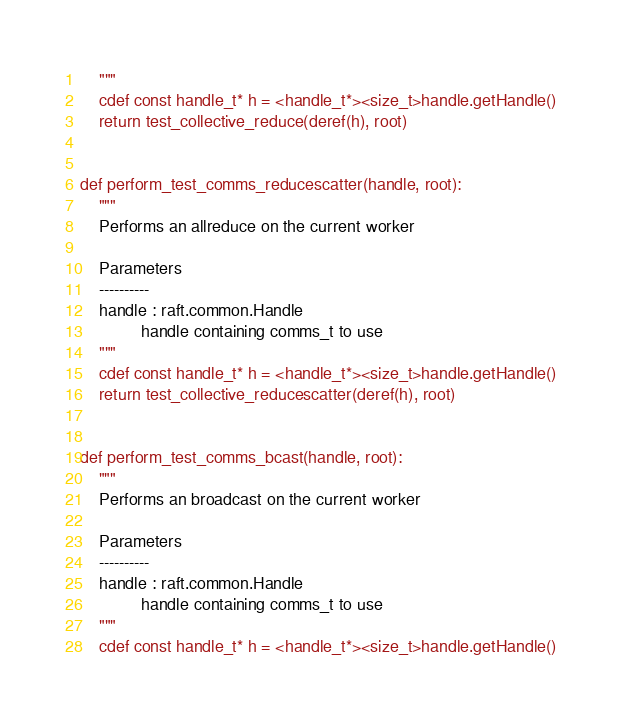Convert code to text. <code><loc_0><loc_0><loc_500><loc_500><_Cython_>    """
    cdef const handle_t* h = <handle_t*><size_t>handle.getHandle()
    return test_collective_reduce(deref(h), root)


def perform_test_comms_reducescatter(handle, root):
    """
    Performs an allreduce on the current worker

    Parameters
    ----------
    handle : raft.common.Handle
             handle containing comms_t to use
    """
    cdef const handle_t* h = <handle_t*><size_t>handle.getHandle()
    return test_collective_reducescatter(deref(h), root)


def perform_test_comms_bcast(handle, root):
    """
    Performs an broadcast on the current worker

    Parameters
    ----------
    handle : raft.common.Handle
             handle containing comms_t to use
    """
    cdef const handle_t* h = <handle_t*><size_t>handle.getHandle()</code> 